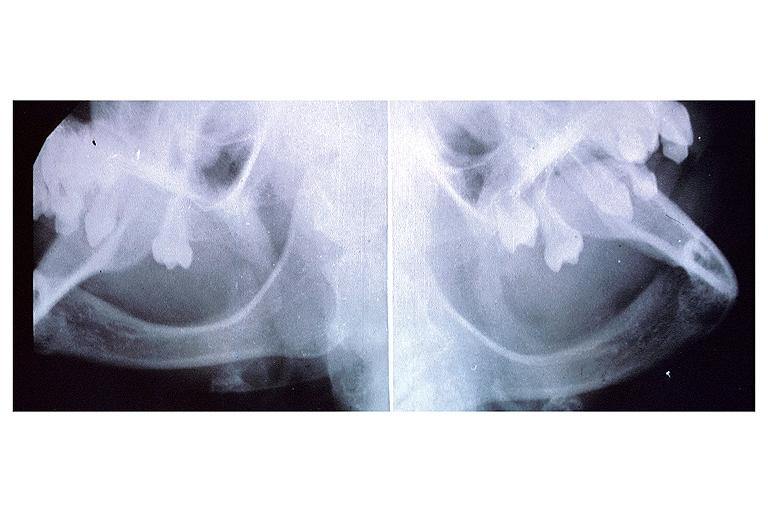s oral present?
Answer the question using a single word or phrase. Yes 